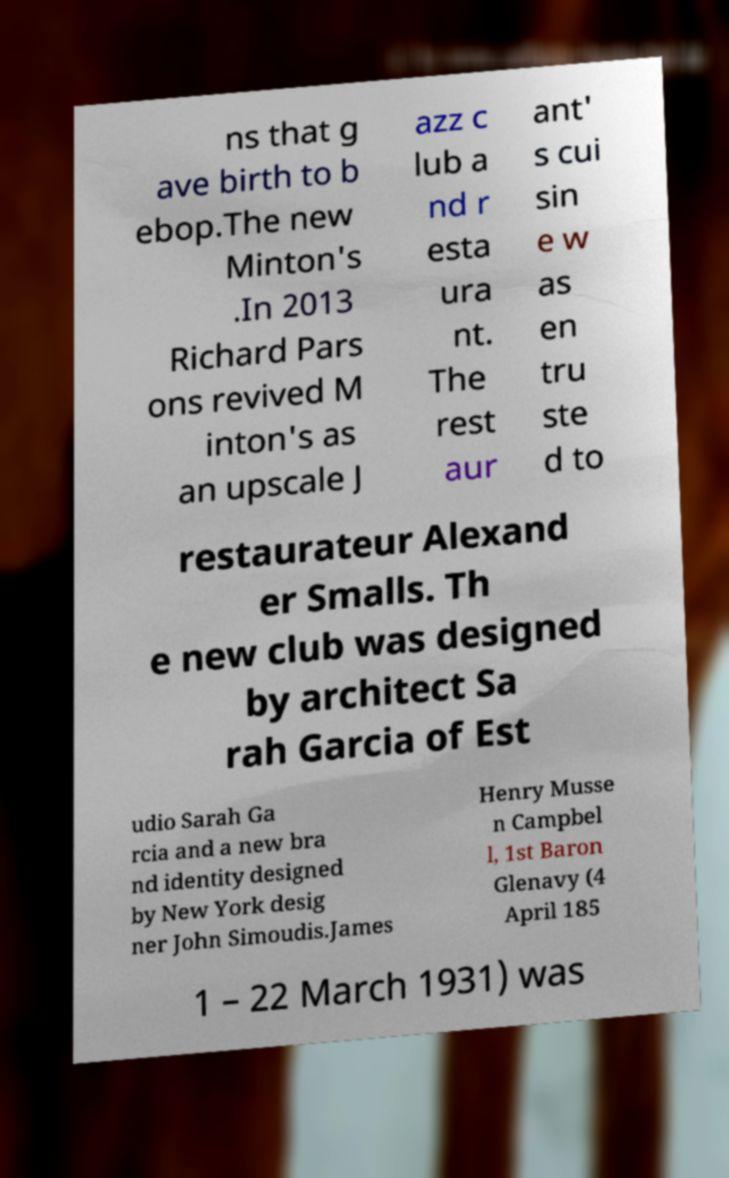Could you assist in decoding the text presented in this image and type it out clearly? ns that g ave birth to b ebop.The new Minton's .In 2013 Richard Pars ons revived M inton's as an upscale J azz c lub a nd r esta ura nt. The rest aur ant' s cui sin e w as en tru ste d to restaurateur Alexand er Smalls. Th e new club was designed by architect Sa rah Garcia of Est udio Sarah Ga rcia and a new bra nd identity designed by New York desig ner John Simoudis.James Henry Musse n Campbel l, 1st Baron Glenavy (4 April 185 1 – 22 March 1931) was 